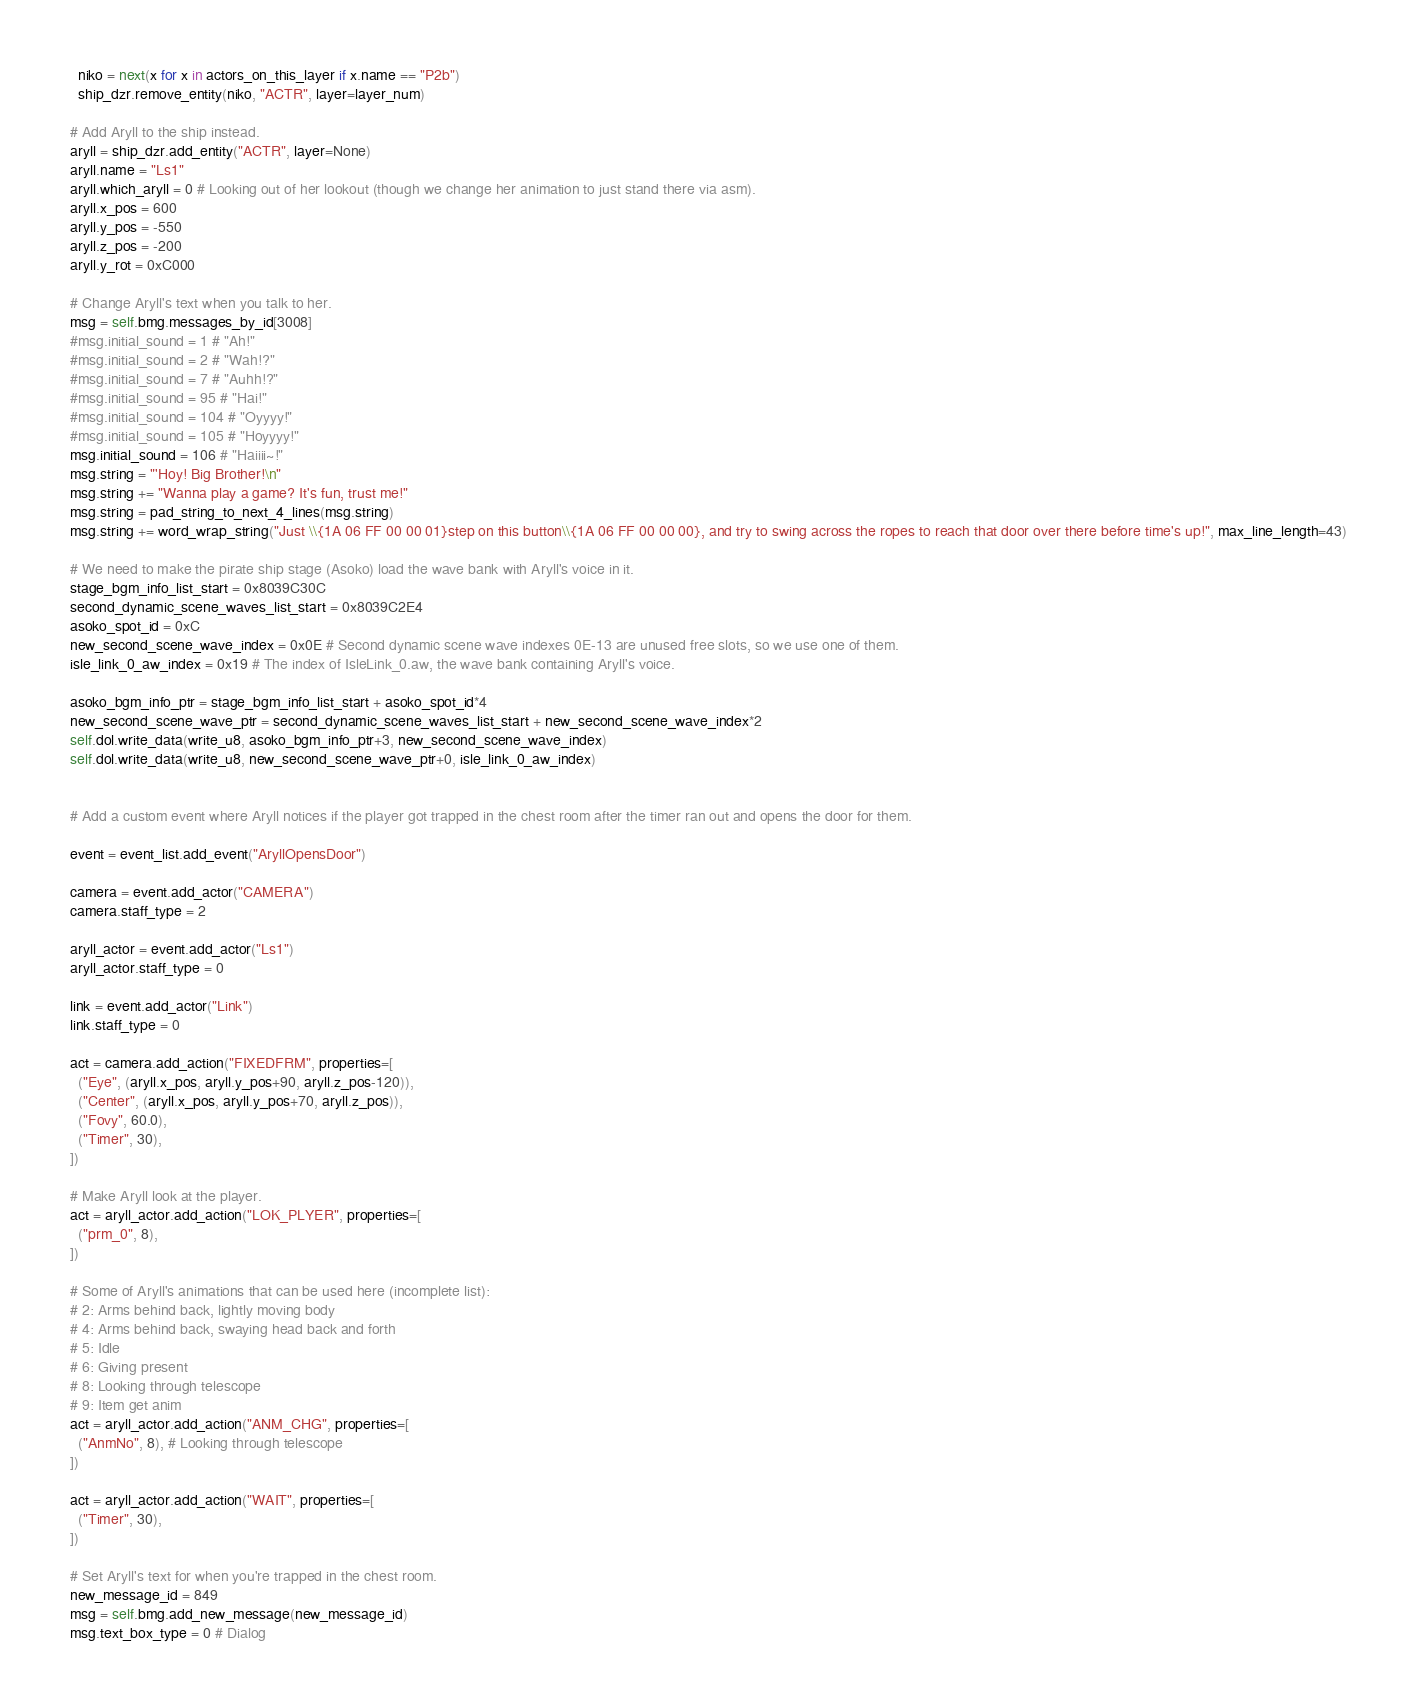<code> <loc_0><loc_0><loc_500><loc_500><_Python_>    niko = next(x for x in actors_on_this_layer if x.name == "P2b")
    ship_dzr.remove_entity(niko, "ACTR", layer=layer_num)
  
  # Add Aryll to the ship instead.
  aryll = ship_dzr.add_entity("ACTR", layer=None)
  aryll.name = "Ls1"
  aryll.which_aryll = 0 # Looking out of her lookout (though we change her animation to just stand there via asm).
  aryll.x_pos = 600
  aryll.y_pos = -550
  aryll.z_pos = -200
  aryll.y_rot = 0xC000
  
  # Change Aryll's text when you talk to her.
  msg = self.bmg.messages_by_id[3008]
  #msg.initial_sound = 1 # "Ah!"
  #msg.initial_sound = 2 # "Wah!?"
  #msg.initial_sound = 7 # "Auhh!?"
  #msg.initial_sound = 95 # "Hai!"
  #msg.initial_sound = 104 # "Oyyyy!"
  #msg.initial_sound = 105 # "Hoyyyy!"
  msg.initial_sound = 106 # "Haiiii~!"
  msg.string = "'Hoy! Big Brother!\n"
  msg.string += "Wanna play a game? It's fun, trust me!"
  msg.string = pad_string_to_next_4_lines(msg.string)
  msg.string += word_wrap_string("Just \\{1A 06 FF 00 00 01}step on this button\\{1A 06 FF 00 00 00}, and try to swing across the ropes to reach that door over there before time's up!", max_line_length=43)
  
  # We need to make the pirate ship stage (Asoko) load the wave bank with Aryll's voice in it.
  stage_bgm_info_list_start = 0x8039C30C
  second_dynamic_scene_waves_list_start = 0x8039C2E4
  asoko_spot_id = 0xC
  new_second_scene_wave_index = 0x0E # Second dynamic scene wave indexes 0E-13 are unused free slots, so we use one of them.
  isle_link_0_aw_index = 0x19 # The index of IsleLink_0.aw, the wave bank containing Aryll's voice.
  
  asoko_bgm_info_ptr = stage_bgm_info_list_start + asoko_spot_id*4
  new_second_scene_wave_ptr = second_dynamic_scene_waves_list_start + new_second_scene_wave_index*2
  self.dol.write_data(write_u8, asoko_bgm_info_ptr+3, new_second_scene_wave_index)
  self.dol.write_data(write_u8, new_second_scene_wave_ptr+0, isle_link_0_aw_index)
  
  
  # Add a custom event where Aryll notices if the player got trapped in the chest room after the timer ran out and opens the door for them.
  
  event = event_list.add_event("AryllOpensDoor")
  
  camera = event.add_actor("CAMERA")
  camera.staff_type = 2
  
  aryll_actor = event.add_actor("Ls1")
  aryll_actor.staff_type = 0
  
  link = event.add_actor("Link")
  link.staff_type = 0
  
  act = camera.add_action("FIXEDFRM", properties=[
    ("Eye", (aryll.x_pos, aryll.y_pos+90, aryll.z_pos-120)),
    ("Center", (aryll.x_pos, aryll.y_pos+70, aryll.z_pos)),
    ("Fovy", 60.0),
    ("Timer", 30),
  ])
  
  # Make Aryll look at the player.
  act = aryll_actor.add_action("LOK_PLYER", properties=[
    ("prm_0", 8),
  ])
  
  # Some of Aryll's animations that can be used here (incomplete list):
  # 2: Arms behind back, lightly moving body
  # 4: Arms behind back, swaying head back and forth
  # 5: Idle
  # 6: Giving present
  # 8: Looking through telescope
  # 9: Item get anim
  act = aryll_actor.add_action("ANM_CHG", properties=[
    ("AnmNo", 8), # Looking through telescope
  ])
  
  act = aryll_actor.add_action("WAIT", properties=[
    ("Timer", 30),
  ])
  
  # Set Aryll's text for when you're trapped in the chest room.
  new_message_id = 849
  msg = self.bmg.add_new_message(new_message_id)
  msg.text_box_type = 0 # Dialog</code> 